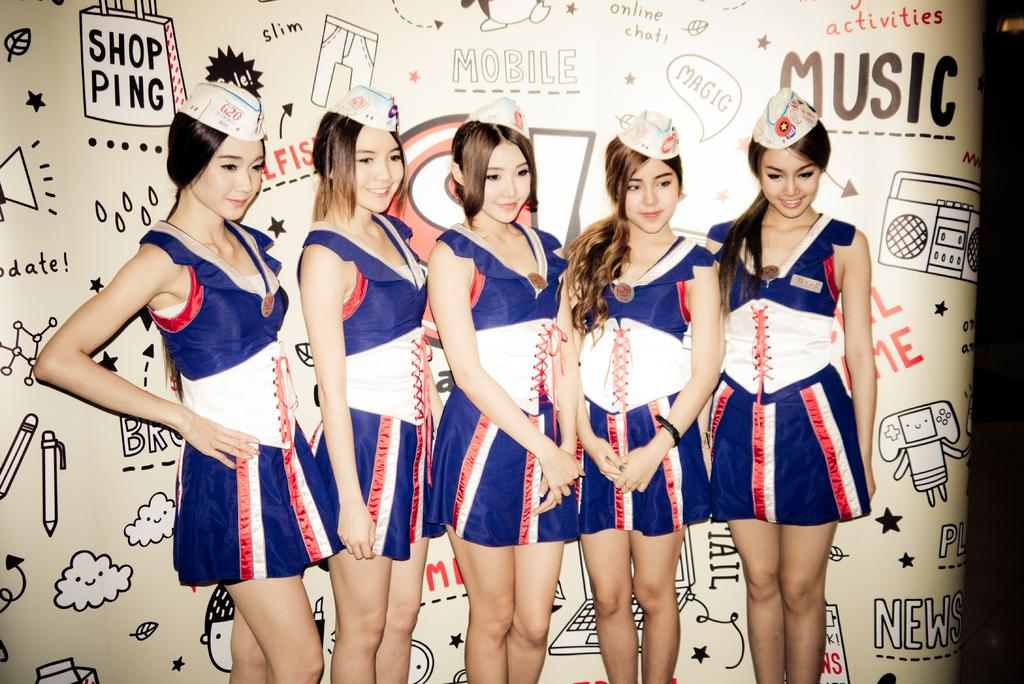<image>
Provide a brief description of the given image. The shopping bag design on the wall behind the left gift says "shopping" 